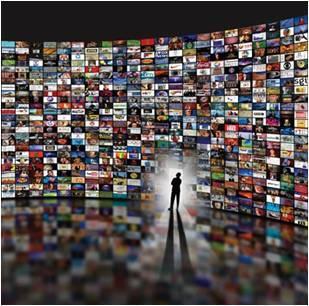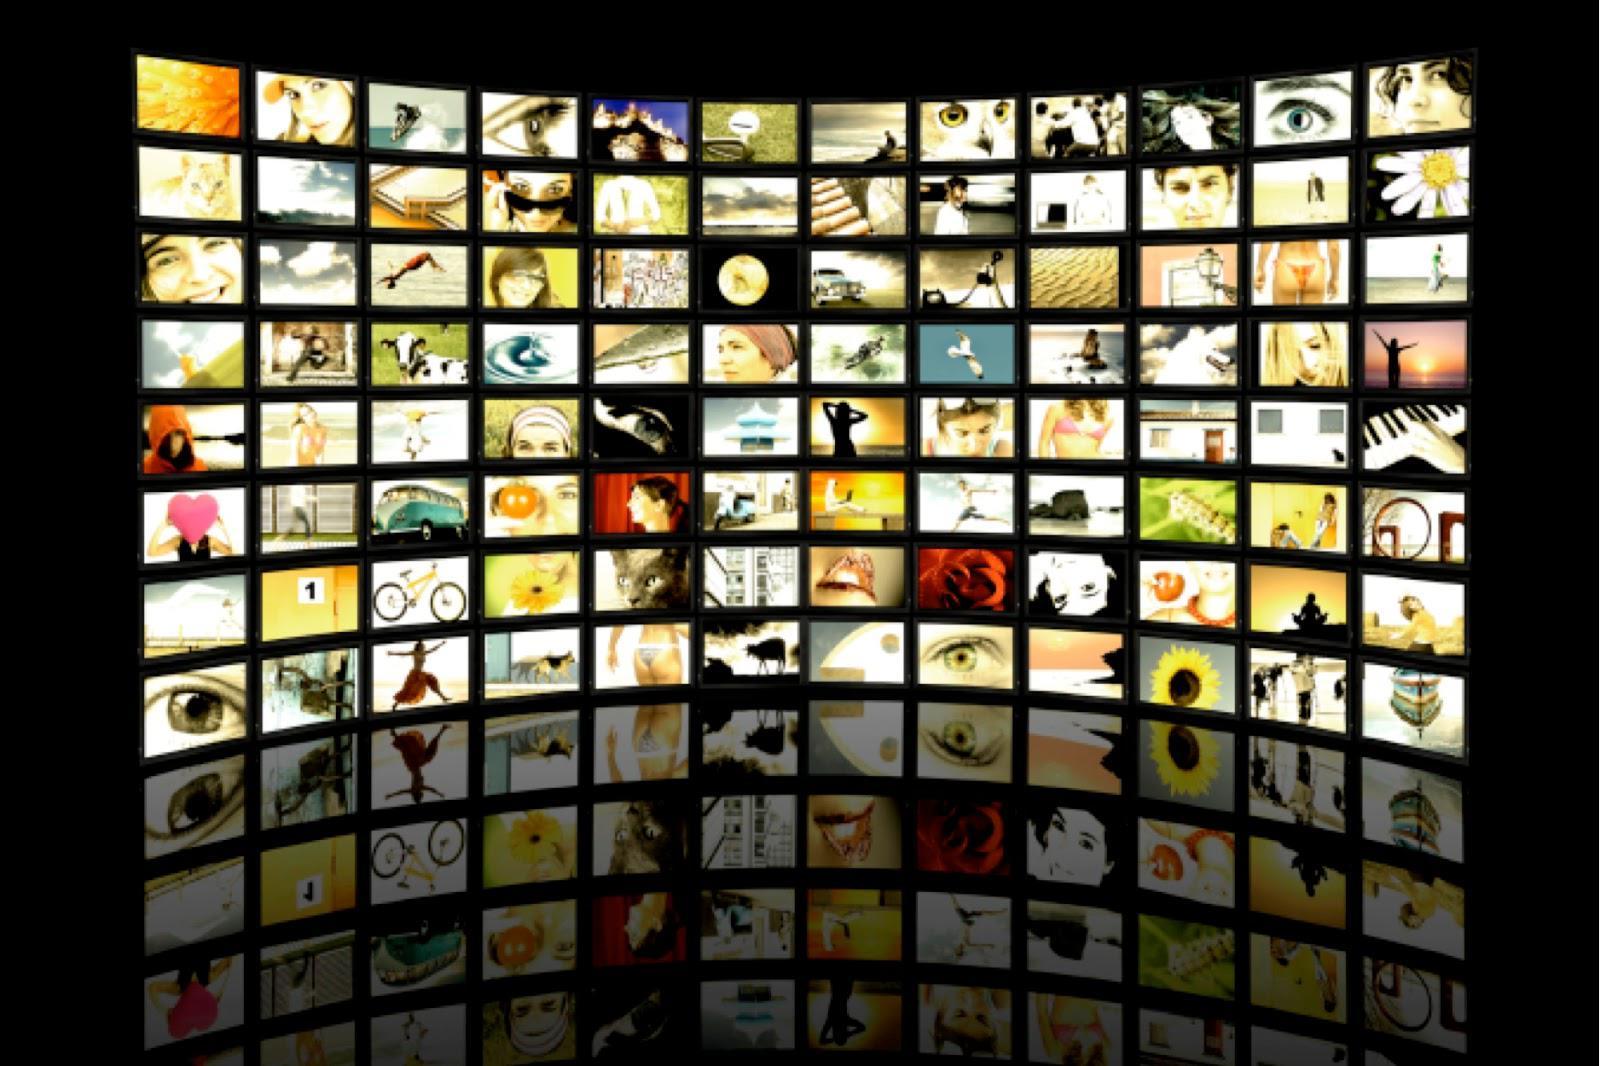The first image is the image on the left, the second image is the image on the right. Analyze the images presented: Is the assertion "An image shows a silhouetted person surrounded by glowing white light and facing a wall of screens filled with pictures." valid? Answer yes or no. Yes. The first image is the image on the left, the second image is the image on the right. Evaluate the accuracy of this statement regarding the images: "A person is standing in front of the screen in the image on the left.". Is it true? Answer yes or no. Yes. 